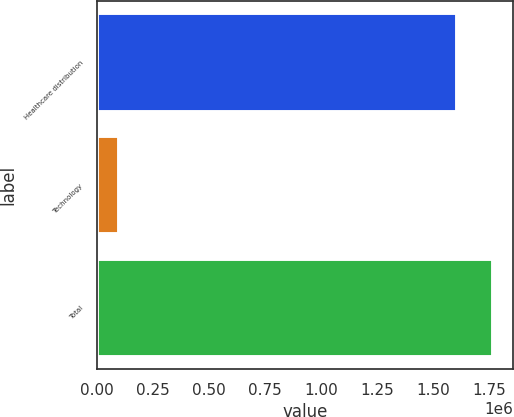Convert chart. <chart><loc_0><loc_0><loc_500><loc_500><bar_chart><fcel>Healthcare distribution<fcel>Technology<fcel>Total<nl><fcel>1.60797e+06<fcel>98125<fcel>1.76876e+06<nl></chart> 